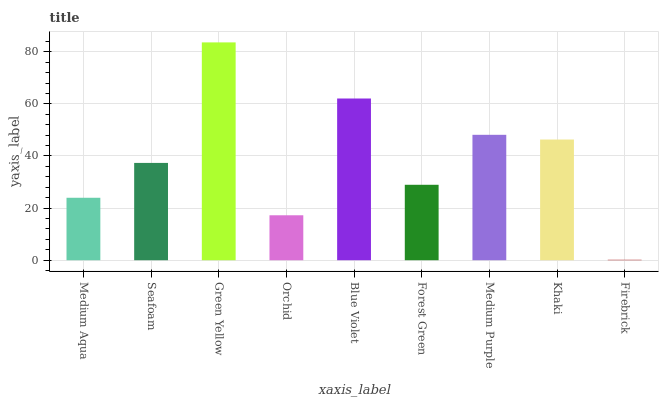Is Firebrick the minimum?
Answer yes or no. Yes. Is Green Yellow the maximum?
Answer yes or no. Yes. Is Seafoam the minimum?
Answer yes or no. No. Is Seafoam the maximum?
Answer yes or no. No. Is Seafoam greater than Medium Aqua?
Answer yes or no. Yes. Is Medium Aqua less than Seafoam?
Answer yes or no. Yes. Is Medium Aqua greater than Seafoam?
Answer yes or no. No. Is Seafoam less than Medium Aqua?
Answer yes or no. No. Is Seafoam the high median?
Answer yes or no. Yes. Is Seafoam the low median?
Answer yes or no. Yes. Is Orchid the high median?
Answer yes or no. No. Is Khaki the low median?
Answer yes or no. No. 